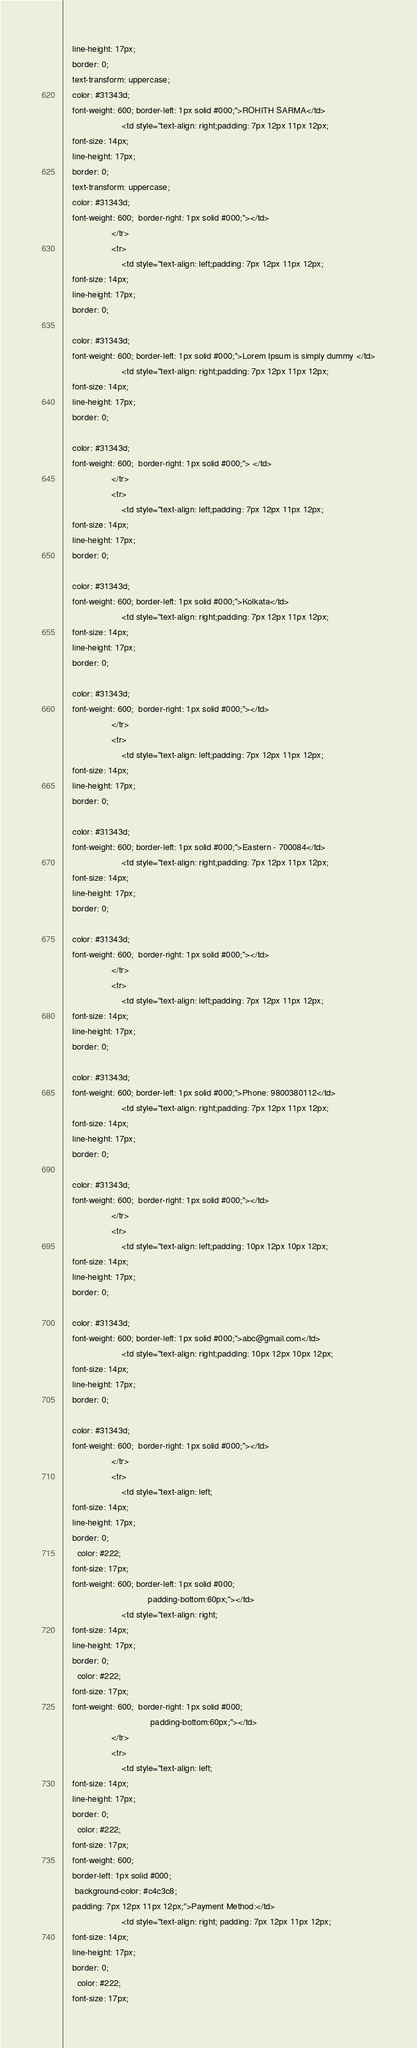Convert code to text. <code><loc_0><loc_0><loc_500><loc_500><_PHP_>    line-height: 17px;
    border: 0;
    text-transform: uppercase;
    color: #31343d;
    font-weight: 600; border-left: 1px solid #000;">ROHITH SARMA</td>
                        <td style="text-align: right;padding: 7px 12px 11px 12px;
    font-size: 14px;
    line-height: 17px;
    border: 0;
    text-transform: uppercase;
    color: #31343d;
    font-weight: 600;  border-right: 1px solid #000;"></td>
                    </tr>
                    <tr>
                        <td style="text-align: left;padding: 7px 12px 11px 12px;
    font-size: 14px;
    line-height: 17px;
    border: 0;
  
    color: #31343d;
    font-weight: 600; border-left: 1px solid #000;">Lorem Ipsum is simply dummy </td>
                        <td style="text-align: right;padding: 7px 12px 11px 12px;
    font-size: 14px;
    line-height: 17px;
    border: 0;
    
    color: #31343d;
    font-weight: 600;  border-right: 1px solid #000;"> </td>
                    </tr>
                    <tr>
                        <td style="text-align: left;padding: 7px 12px 11px 12px;
    font-size: 14px;
    line-height: 17px;
    border: 0;
  
    color: #31343d;
    font-weight: 600; border-left: 1px solid #000;">Kolkata</td>
                        <td style="text-align: right;padding: 7px 12px 11px 12px;
    font-size: 14px;
    line-height: 17px;
    border: 0;
    
    color: #31343d;
    font-weight: 600;  border-right: 1px solid #000;"></td>
                    </tr>
                    <tr>
                        <td style="text-align: left;padding: 7px 12px 11px 12px;
    font-size: 14px;
    line-height: 17px;
    border: 0;
   
    color: #31343d;
    font-weight: 600; border-left: 1px solid #000;">Eastern - 700084</td>
                        <td style="text-align: right;padding: 7px 12px 11px 12px;
    font-size: 14px;
    line-height: 17px;
    border: 0;
   
    color: #31343d;
    font-weight: 600;  border-right: 1px solid #000;"></td>
                    </tr>
                    <tr>
                        <td style="text-align: left;padding: 7px 12px 11px 12px;
    font-size: 14px;
    line-height: 17px;
    border: 0;
   
    color: #31343d;
    font-weight: 600; border-left: 1px solid #000;">Phone: 9800380112</td>
                        <td style="text-align: right;padding: 7px 12px 11px 12px;
    font-size: 14px;
    line-height: 17px;
    border: 0;
   
    color: #31343d;
    font-weight: 600;  border-right: 1px solid #000;"></td>
                    </tr>
                    <tr>
                        <td style="text-align: left;padding: 10px 12px 10px 12px;
    font-size: 14px;
    line-height: 17px;
    border: 0;
   
    color: #31343d;
    font-weight: 600; border-left: 1px solid #000;">abc@gmail.com</td>
                        <td style="text-align: right;padding: 10px 12px 10px 12px;
    font-size: 14px;
    line-height: 17px;
    border: 0;
   
    color: #31343d;
    font-weight: 600;  border-right: 1px solid #000;"></td>
                    </tr>
                    <tr>
                        <td style="text-align: left;
    font-size: 14px;
    line-height: 17px;
    border: 0;
      color: #222;
    font-size: 17px;
    font-weight: 600; border-left: 1px solid #000;
                                   padding-bottom:60px;"></td>
                        <td style="text-align: right;
    font-size: 14px;
    line-height: 17px;
    border: 0;
      color: #222;
    font-size: 17px;
    font-weight: 600;  border-right: 1px solid #000; 
                                    padding-bottom:60px;"></td>
                    </tr>
                    <tr>
                        <td style="text-align: left;
    font-size: 14px;
    line-height: 17px;
    border: 0;
      color: #222;
    font-size: 17px;
    font-weight: 600;
    border-left: 1px solid #000;
     background-color: #c4c3c8;
    padding: 7px 12px 11px 12px;">Payment Method:</td>
                        <td style="text-align: right; padding: 7px 12px 11px 12px;
    font-size: 14px;
    line-height: 17px;
    border: 0;
      color: #222;
    font-size: 17px;</code> 